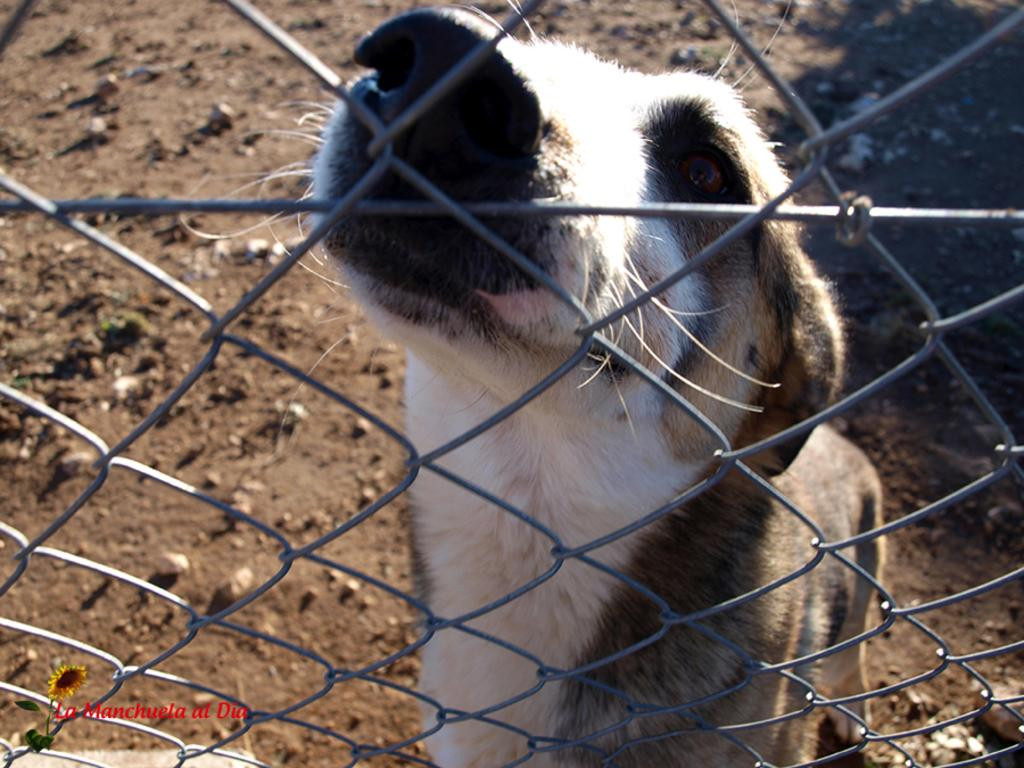What type of animal is in the image? There is an animal in the image, but the specific type cannot be determined from the provided facts. What colors can be seen on the animal? The animal has white, black, and brown colors. What is in front of the animal? There is net fencing in front of the animal. How would you describe the ground in the image? The ground is muddy. What type of approval does the pig need to cross the metal fence in the image? There is no pig present in the image, and there is no mention of approval or metal fencing in the provided facts. 